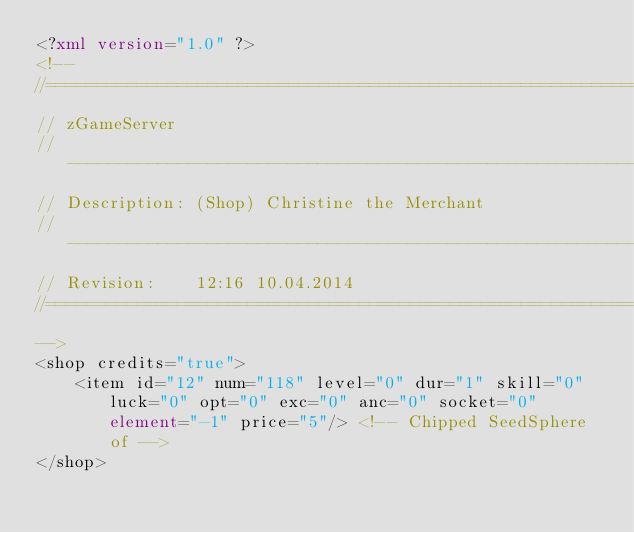Convert code to text. <code><loc_0><loc_0><loc_500><loc_500><_XML_><?xml version="1.0" ?>
<!-- 
//===================================================================================
// zGameServer
// ----------------------------------------------------------------------------------
// Description:	(Shop) Christine the Merchant
// ----------------------------------------------------------------------------------
// Revision: 	12:16 10.04.2014
//===================================================================================
-->
<shop credits="true">
 	<item id="12" num="118" level="0" dur="1" skill="0" luck="0" opt="0" exc="0" anc="0" socket="0" element="-1" price="5"/> <!-- Chipped SeedSphere of -->
</shop></code> 